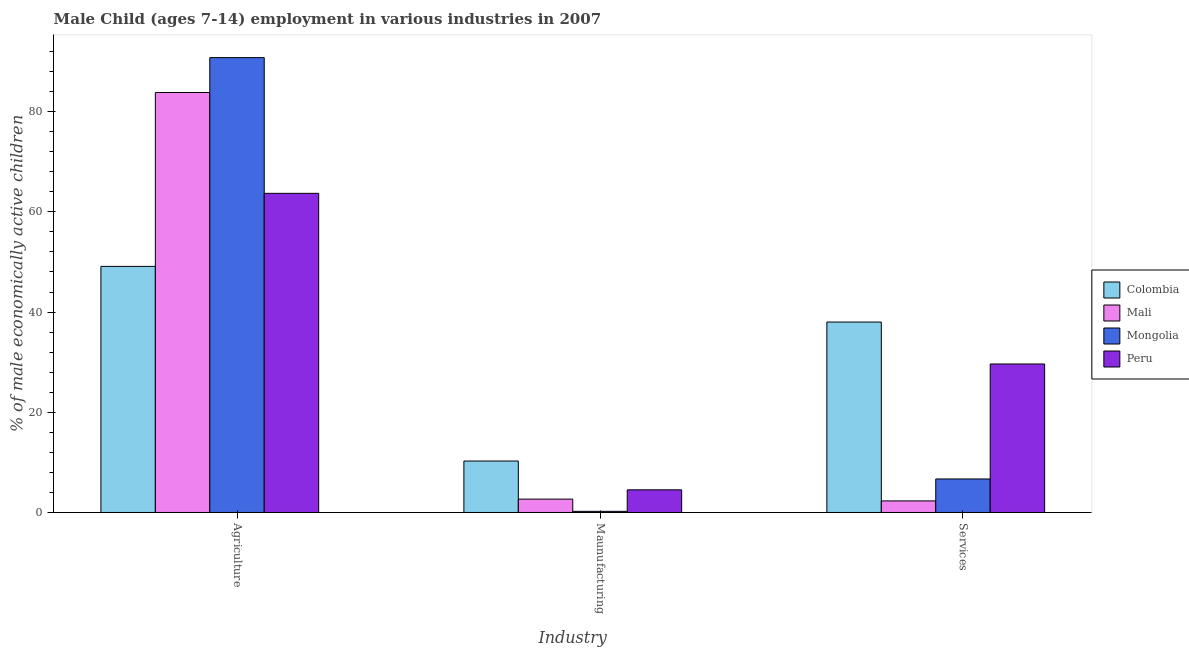How many groups of bars are there?
Provide a succinct answer. 3. How many bars are there on the 3rd tick from the left?
Offer a very short reply. 4. What is the label of the 1st group of bars from the left?
Ensure brevity in your answer.  Agriculture. What is the percentage of economically active children in manufacturing in Mali?
Give a very brief answer. 2.67. Across all countries, what is the maximum percentage of economically active children in services?
Your response must be concise. 38.01. Across all countries, what is the minimum percentage of economically active children in services?
Give a very brief answer. 2.31. In which country was the percentage of economically active children in services maximum?
Keep it short and to the point. Colombia. What is the total percentage of economically active children in services in the graph?
Provide a short and direct response. 76.65. What is the difference between the percentage of economically active children in manufacturing in Mongolia and that in Colombia?
Offer a terse response. -10.04. What is the difference between the percentage of economically active children in manufacturing in Mongolia and the percentage of economically active children in services in Mali?
Give a very brief answer. -2.08. What is the average percentage of economically active children in services per country?
Keep it short and to the point. 19.16. What is the difference between the percentage of economically active children in agriculture and percentage of economically active children in services in Colombia?
Make the answer very short. 11.11. What is the ratio of the percentage of economically active children in services in Mali to that in Mongolia?
Your answer should be compact. 0.35. Is the percentage of economically active children in services in Mali less than that in Mongolia?
Give a very brief answer. Yes. What is the difference between the highest and the second highest percentage of economically active children in manufacturing?
Provide a short and direct response. 5.75. What is the difference between the highest and the lowest percentage of economically active children in services?
Your answer should be compact. 35.7. In how many countries, is the percentage of economically active children in manufacturing greater than the average percentage of economically active children in manufacturing taken over all countries?
Provide a succinct answer. 2. Is the sum of the percentage of economically active children in services in Colombia and Mali greater than the maximum percentage of economically active children in manufacturing across all countries?
Your answer should be compact. Yes. What does the 2nd bar from the left in Services represents?
Provide a succinct answer. Mali. What does the 4th bar from the right in Maunufacturing represents?
Give a very brief answer. Colombia. Is it the case that in every country, the sum of the percentage of economically active children in agriculture and percentage of economically active children in manufacturing is greater than the percentage of economically active children in services?
Provide a short and direct response. Yes. How many countries are there in the graph?
Offer a terse response. 4. What is the difference between two consecutive major ticks on the Y-axis?
Your answer should be very brief. 20. Are the values on the major ticks of Y-axis written in scientific E-notation?
Provide a succinct answer. No. Does the graph contain any zero values?
Offer a terse response. No. Does the graph contain grids?
Provide a short and direct response. No. Where does the legend appear in the graph?
Ensure brevity in your answer.  Center right. How are the legend labels stacked?
Offer a very short reply. Vertical. What is the title of the graph?
Provide a short and direct response. Male Child (ages 7-14) employment in various industries in 2007. What is the label or title of the X-axis?
Your response must be concise. Industry. What is the label or title of the Y-axis?
Make the answer very short. % of male economically active children. What is the % of male economically active children of Colombia in Agriculture?
Give a very brief answer. 49.12. What is the % of male economically active children of Mali in Agriculture?
Provide a short and direct response. 83.83. What is the % of male economically active children of Mongolia in Agriculture?
Offer a terse response. 90.79. What is the % of male economically active children in Peru in Agriculture?
Offer a terse response. 63.7. What is the % of male economically active children in Colombia in Maunufacturing?
Offer a terse response. 10.27. What is the % of male economically active children in Mali in Maunufacturing?
Give a very brief answer. 2.67. What is the % of male economically active children in Mongolia in Maunufacturing?
Keep it short and to the point. 0.23. What is the % of male economically active children of Peru in Maunufacturing?
Offer a terse response. 4.52. What is the % of male economically active children of Colombia in Services?
Ensure brevity in your answer.  38.01. What is the % of male economically active children in Mali in Services?
Keep it short and to the point. 2.31. What is the % of male economically active children in Mongolia in Services?
Ensure brevity in your answer.  6.69. What is the % of male economically active children in Peru in Services?
Your response must be concise. 29.64. Across all Industry, what is the maximum % of male economically active children in Colombia?
Offer a very short reply. 49.12. Across all Industry, what is the maximum % of male economically active children of Mali?
Your answer should be compact. 83.83. Across all Industry, what is the maximum % of male economically active children in Mongolia?
Ensure brevity in your answer.  90.79. Across all Industry, what is the maximum % of male economically active children in Peru?
Provide a succinct answer. 63.7. Across all Industry, what is the minimum % of male economically active children in Colombia?
Offer a terse response. 10.27. Across all Industry, what is the minimum % of male economically active children of Mali?
Provide a succinct answer. 2.31. Across all Industry, what is the minimum % of male economically active children of Mongolia?
Your answer should be very brief. 0.23. Across all Industry, what is the minimum % of male economically active children in Peru?
Provide a succinct answer. 4.52. What is the total % of male economically active children in Colombia in the graph?
Your answer should be very brief. 97.4. What is the total % of male economically active children in Mali in the graph?
Keep it short and to the point. 88.81. What is the total % of male economically active children of Mongolia in the graph?
Keep it short and to the point. 97.71. What is the total % of male economically active children of Peru in the graph?
Offer a very short reply. 97.86. What is the difference between the % of male economically active children of Colombia in Agriculture and that in Maunufacturing?
Ensure brevity in your answer.  38.85. What is the difference between the % of male economically active children in Mali in Agriculture and that in Maunufacturing?
Provide a succinct answer. 81.16. What is the difference between the % of male economically active children of Mongolia in Agriculture and that in Maunufacturing?
Keep it short and to the point. 90.56. What is the difference between the % of male economically active children of Peru in Agriculture and that in Maunufacturing?
Offer a very short reply. 59.18. What is the difference between the % of male economically active children of Colombia in Agriculture and that in Services?
Keep it short and to the point. 11.11. What is the difference between the % of male economically active children in Mali in Agriculture and that in Services?
Your answer should be compact. 81.52. What is the difference between the % of male economically active children in Mongolia in Agriculture and that in Services?
Your answer should be very brief. 84.1. What is the difference between the % of male economically active children in Peru in Agriculture and that in Services?
Ensure brevity in your answer.  34.06. What is the difference between the % of male economically active children in Colombia in Maunufacturing and that in Services?
Your answer should be very brief. -27.74. What is the difference between the % of male economically active children in Mali in Maunufacturing and that in Services?
Offer a terse response. 0.36. What is the difference between the % of male economically active children of Mongolia in Maunufacturing and that in Services?
Provide a succinct answer. -6.46. What is the difference between the % of male economically active children in Peru in Maunufacturing and that in Services?
Offer a very short reply. -25.12. What is the difference between the % of male economically active children in Colombia in Agriculture and the % of male economically active children in Mali in Maunufacturing?
Your response must be concise. 46.45. What is the difference between the % of male economically active children in Colombia in Agriculture and the % of male economically active children in Mongolia in Maunufacturing?
Your answer should be very brief. 48.89. What is the difference between the % of male economically active children of Colombia in Agriculture and the % of male economically active children of Peru in Maunufacturing?
Provide a short and direct response. 44.6. What is the difference between the % of male economically active children in Mali in Agriculture and the % of male economically active children in Mongolia in Maunufacturing?
Provide a succinct answer. 83.6. What is the difference between the % of male economically active children in Mali in Agriculture and the % of male economically active children in Peru in Maunufacturing?
Your response must be concise. 79.31. What is the difference between the % of male economically active children in Mongolia in Agriculture and the % of male economically active children in Peru in Maunufacturing?
Your answer should be very brief. 86.27. What is the difference between the % of male economically active children in Colombia in Agriculture and the % of male economically active children in Mali in Services?
Offer a very short reply. 46.81. What is the difference between the % of male economically active children of Colombia in Agriculture and the % of male economically active children of Mongolia in Services?
Offer a terse response. 42.43. What is the difference between the % of male economically active children in Colombia in Agriculture and the % of male economically active children in Peru in Services?
Offer a terse response. 19.48. What is the difference between the % of male economically active children in Mali in Agriculture and the % of male economically active children in Mongolia in Services?
Make the answer very short. 77.14. What is the difference between the % of male economically active children of Mali in Agriculture and the % of male economically active children of Peru in Services?
Provide a succinct answer. 54.19. What is the difference between the % of male economically active children of Mongolia in Agriculture and the % of male economically active children of Peru in Services?
Your response must be concise. 61.15. What is the difference between the % of male economically active children of Colombia in Maunufacturing and the % of male economically active children of Mali in Services?
Provide a short and direct response. 7.96. What is the difference between the % of male economically active children of Colombia in Maunufacturing and the % of male economically active children of Mongolia in Services?
Make the answer very short. 3.58. What is the difference between the % of male economically active children of Colombia in Maunufacturing and the % of male economically active children of Peru in Services?
Offer a very short reply. -19.37. What is the difference between the % of male economically active children of Mali in Maunufacturing and the % of male economically active children of Mongolia in Services?
Give a very brief answer. -4.02. What is the difference between the % of male economically active children of Mali in Maunufacturing and the % of male economically active children of Peru in Services?
Make the answer very short. -26.97. What is the difference between the % of male economically active children of Mongolia in Maunufacturing and the % of male economically active children of Peru in Services?
Keep it short and to the point. -29.41. What is the average % of male economically active children of Colombia per Industry?
Keep it short and to the point. 32.47. What is the average % of male economically active children of Mali per Industry?
Your answer should be compact. 29.6. What is the average % of male economically active children of Mongolia per Industry?
Provide a short and direct response. 32.57. What is the average % of male economically active children in Peru per Industry?
Your answer should be very brief. 32.62. What is the difference between the % of male economically active children in Colombia and % of male economically active children in Mali in Agriculture?
Make the answer very short. -34.71. What is the difference between the % of male economically active children in Colombia and % of male economically active children in Mongolia in Agriculture?
Ensure brevity in your answer.  -41.67. What is the difference between the % of male economically active children of Colombia and % of male economically active children of Peru in Agriculture?
Give a very brief answer. -14.58. What is the difference between the % of male economically active children of Mali and % of male economically active children of Mongolia in Agriculture?
Offer a terse response. -6.96. What is the difference between the % of male economically active children of Mali and % of male economically active children of Peru in Agriculture?
Provide a succinct answer. 20.13. What is the difference between the % of male economically active children of Mongolia and % of male economically active children of Peru in Agriculture?
Offer a very short reply. 27.09. What is the difference between the % of male economically active children in Colombia and % of male economically active children in Mali in Maunufacturing?
Make the answer very short. 7.6. What is the difference between the % of male economically active children in Colombia and % of male economically active children in Mongolia in Maunufacturing?
Keep it short and to the point. 10.04. What is the difference between the % of male economically active children in Colombia and % of male economically active children in Peru in Maunufacturing?
Offer a very short reply. 5.75. What is the difference between the % of male economically active children of Mali and % of male economically active children of Mongolia in Maunufacturing?
Ensure brevity in your answer.  2.44. What is the difference between the % of male economically active children in Mali and % of male economically active children in Peru in Maunufacturing?
Your answer should be very brief. -1.85. What is the difference between the % of male economically active children of Mongolia and % of male economically active children of Peru in Maunufacturing?
Offer a terse response. -4.29. What is the difference between the % of male economically active children in Colombia and % of male economically active children in Mali in Services?
Make the answer very short. 35.7. What is the difference between the % of male economically active children in Colombia and % of male economically active children in Mongolia in Services?
Keep it short and to the point. 31.32. What is the difference between the % of male economically active children in Colombia and % of male economically active children in Peru in Services?
Keep it short and to the point. 8.37. What is the difference between the % of male economically active children in Mali and % of male economically active children in Mongolia in Services?
Make the answer very short. -4.38. What is the difference between the % of male economically active children of Mali and % of male economically active children of Peru in Services?
Make the answer very short. -27.33. What is the difference between the % of male economically active children of Mongolia and % of male economically active children of Peru in Services?
Give a very brief answer. -22.95. What is the ratio of the % of male economically active children in Colombia in Agriculture to that in Maunufacturing?
Your answer should be very brief. 4.78. What is the ratio of the % of male economically active children in Mali in Agriculture to that in Maunufacturing?
Provide a short and direct response. 31.4. What is the ratio of the % of male economically active children of Mongolia in Agriculture to that in Maunufacturing?
Ensure brevity in your answer.  394.74. What is the ratio of the % of male economically active children in Peru in Agriculture to that in Maunufacturing?
Make the answer very short. 14.09. What is the ratio of the % of male economically active children of Colombia in Agriculture to that in Services?
Your answer should be compact. 1.29. What is the ratio of the % of male economically active children of Mali in Agriculture to that in Services?
Your response must be concise. 36.29. What is the ratio of the % of male economically active children of Mongolia in Agriculture to that in Services?
Provide a succinct answer. 13.57. What is the ratio of the % of male economically active children in Peru in Agriculture to that in Services?
Offer a terse response. 2.15. What is the ratio of the % of male economically active children of Colombia in Maunufacturing to that in Services?
Keep it short and to the point. 0.27. What is the ratio of the % of male economically active children of Mali in Maunufacturing to that in Services?
Your response must be concise. 1.16. What is the ratio of the % of male economically active children in Mongolia in Maunufacturing to that in Services?
Give a very brief answer. 0.03. What is the ratio of the % of male economically active children in Peru in Maunufacturing to that in Services?
Your answer should be compact. 0.15. What is the difference between the highest and the second highest % of male economically active children of Colombia?
Ensure brevity in your answer.  11.11. What is the difference between the highest and the second highest % of male economically active children in Mali?
Offer a terse response. 81.16. What is the difference between the highest and the second highest % of male economically active children in Mongolia?
Provide a short and direct response. 84.1. What is the difference between the highest and the second highest % of male economically active children of Peru?
Your answer should be very brief. 34.06. What is the difference between the highest and the lowest % of male economically active children of Colombia?
Provide a succinct answer. 38.85. What is the difference between the highest and the lowest % of male economically active children of Mali?
Your response must be concise. 81.52. What is the difference between the highest and the lowest % of male economically active children of Mongolia?
Make the answer very short. 90.56. What is the difference between the highest and the lowest % of male economically active children of Peru?
Keep it short and to the point. 59.18. 